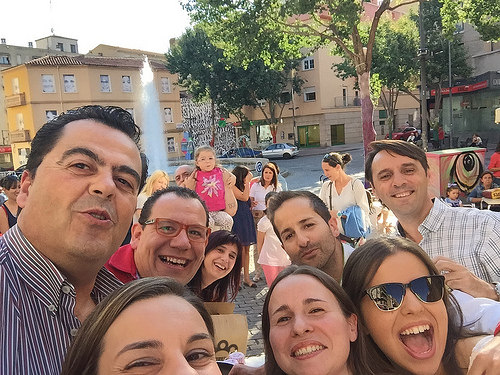<image>
Is there a sunglasses on the person? No. The sunglasses is not positioned on the person. They may be near each other, but the sunglasses is not supported by or resting on top of the person. Is the tree to the left of the building? No. The tree is not to the left of the building. From this viewpoint, they have a different horizontal relationship. 